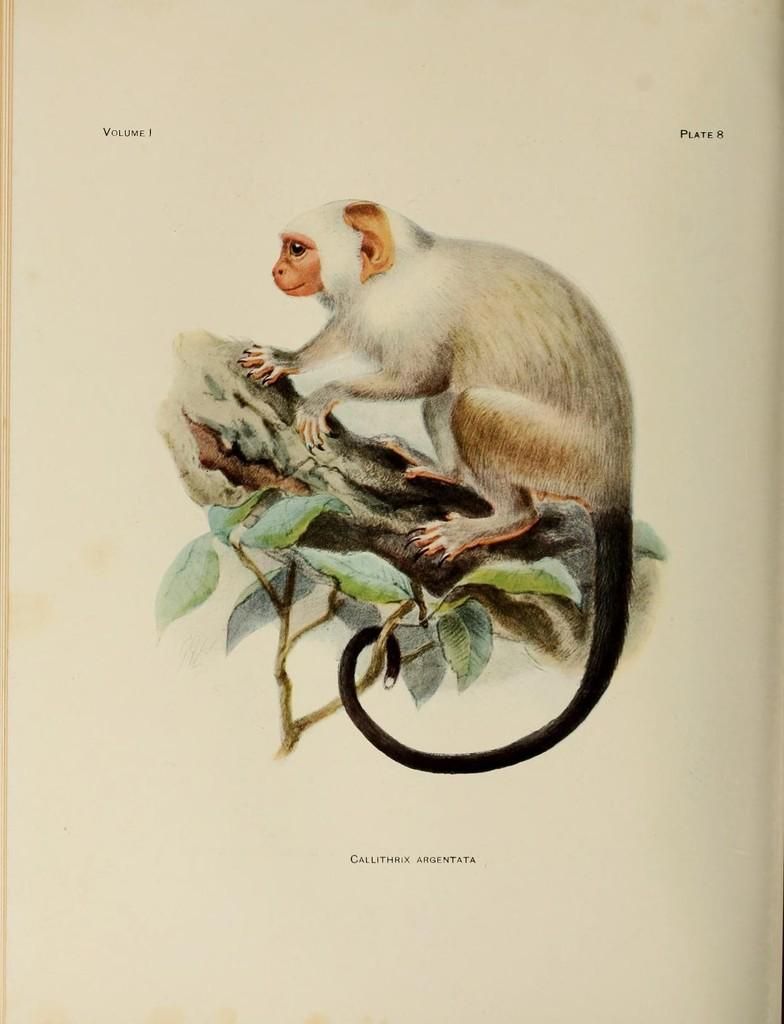What is the main subject of the image? There is a painting in the image. What is depicted in the painting? The painting depicts a monkey. What is the monkey doing in the painting? The monkey is standing on a tree in the painting. What type of apparel is the monkey wearing in the painting? There is no apparel mentioned or depicted on the monkey in the painting. 